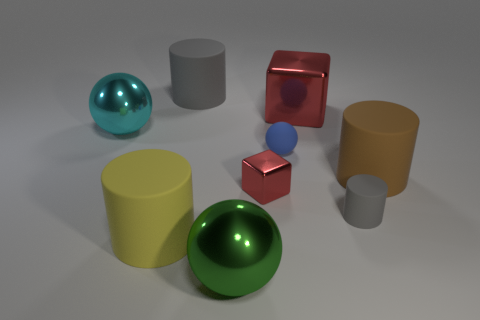Subtract all blocks. How many objects are left? 7 Add 8 large red cylinders. How many large red cylinders exist? 8 Subtract 1 yellow cylinders. How many objects are left? 8 Subtract all large brown matte objects. Subtract all purple objects. How many objects are left? 8 Add 1 cyan metallic objects. How many cyan metallic objects are left? 2 